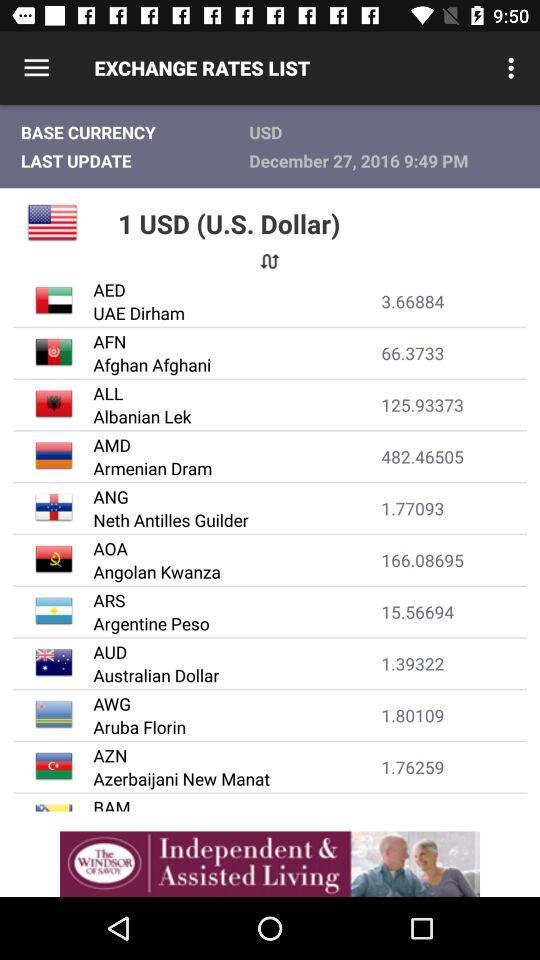What is the value of 1 USD in Angolan Kwanza? The value of 1 USD in Angolan Kwanza is 166.08695. 